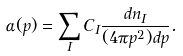Convert formula to latex. <formula><loc_0><loc_0><loc_500><loc_500>\alpha ( p ) = \sum _ { I } C _ { I } \frac { d n _ { I } } { ( 4 \pi { p ^ { 2 } } ) d p } .</formula> 